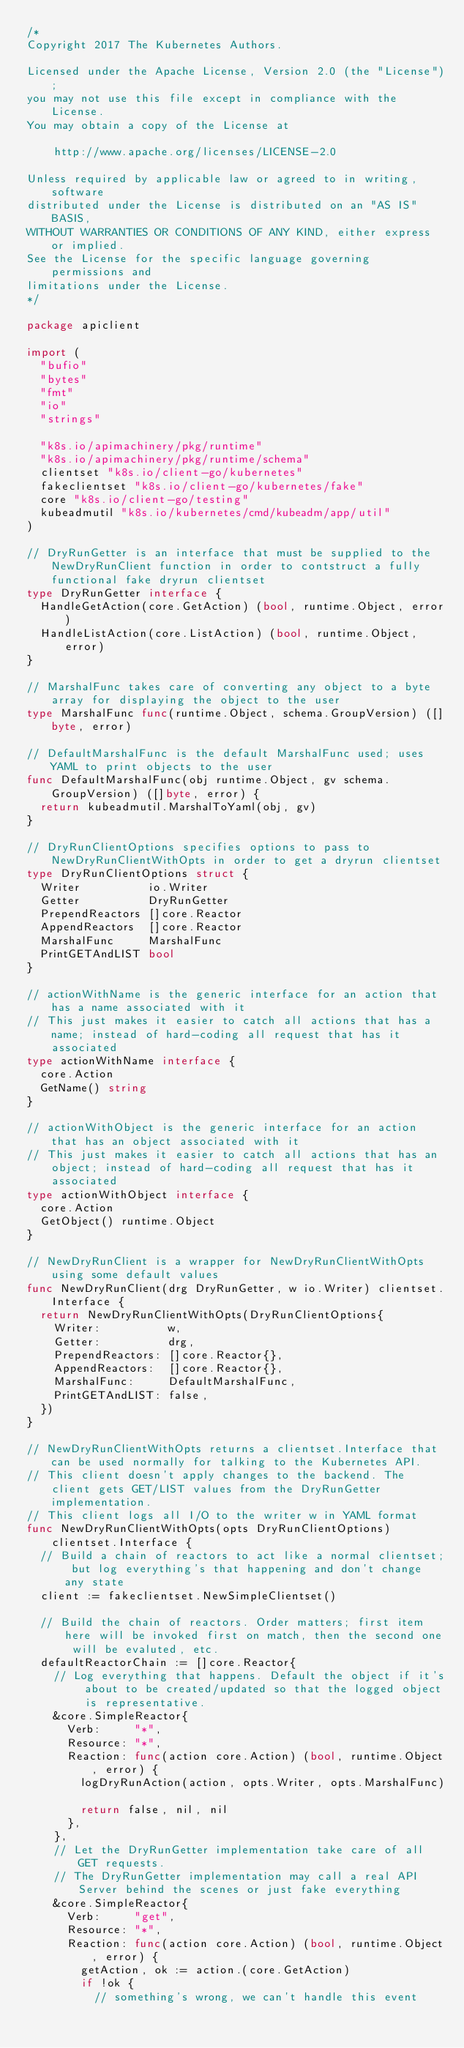Convert code to text. <code><loc_0><loc_0><loc_500><loc_500><_Go_>/*
Copyright 2017 The Kubernetes Authors.

Licensed under the Apache License, Version 2.0 (the "License");
you may not use this file except in compliance with the License.
You may obtain a copy of the License at

    http://www.apache.org/licenses/LICENSE-2.0

Unless required by applicable law or agreed to in writing, software
distributed under the License is distributed on an "AS IS" BASIS,
WITHOUT WARRANTIES OR CONDITIONS OF ANY KIND, either express or implied.
See the License for the specific language governing permissions and
limitations under the License.
*/

package apiclient

import (
	"bufio"
	"bytes"
	"fmt"
	"io"
	"strings"

	"k8s.io/apimachinery/pkg/runtime"
	"k8s.io/apimachinery/pkg/runtime/schema"
	clientset "k8s.io/client-go/kubernetes"
	fakeclientset "k8s.io/client-go/kubernetes/fake"
	core "k8s.io/client-go/testing"
	kubeadmutil "k8s.io/kubernetes/cmd/kubeadm/app/util"
)

// DryRunGetter is an interface that must be supplied to the NewDryRunClient function in order to contstruct a fully functional fake dryrun clientset
type DryRunGetter interface {
	HandleGetAction(core.GetAction) (bool, runtime.Object, error)
	HandleListAction(core.ListAction) (bool, runtime.Object, error)
}

// MarshalFunc takes care of converting any object to a byte array for displaying the object to the user
type MarshalFunc func(runtime.Object, schema.GroupVersion) ([]byte, error)

// DefaultMarshalFunc is the default MarshalFunc used; uses YAML to print objects to the user
func DefaultMarshalFunc(obj runtime.Object, gv schema.GroupVersion) ([]byte, error) {
	return kubeadmutil.MarshalToYaml(obj, gv)
}

// DryRunClientOptions specifies options to pass to NewDryRunClientWithOpts in order to get a dryrun clientset
type DryRunClientOptions struct {
	Writer          io.Writer
	Getter          DryRunGetter
	PrependReactors []core.Reactor
	AppendReactors  []core.Reactor
	MarshalFunc     MarshalFunc
	PrintGETAndLIST bool
}

// actionWithName is the generic interface for an action that has a name associated with it
// This just makes it easier to catch all actions that has a name; instead of hard-coding all request that has it associated
type actionWithName interface {
	core.Action
	GetName() string
}

// actionWithObject is the generic interface for an action that has an object associated with it
// This just makes it easier to catch all actions that has an object; instead of hard-coding all request that has it associated
type actionWithObject interface {
	core.Action
	GetObject() runtime.Object
}

// NewDryRunClient is a wrapper for NewDryRunClientWithOpts using some default values
func NewDryRunClient(drg DryRunGetter, w io.Writer) clientset.Interface {
	return NewDryRunClientWithOpts(DryRunClientOptions{
		Writer:          w,
		Getter:          drg,
		PrependReactors: []core.Reactor{},
		AppendReactors:  []core.Reactor{},
		MarshalFunc:     DefaultMarshalFunc,
		PrintGETAndLIST: false,
	})
}

// NewDryRunClientWithOpts returns a clientset.Interface that can be used normally for talking to the Kubernetes API.
// This client doesn't apply changes to the backend. The client gets GET/LIST values from the DryRunGetter implementation.
// This client logs all I/O to the writer w in YAML format
func NewDryRunClientWithOpts(opts DryRunClientOptions) clientset.Interface {
	// Build a chain of reactors to act like a normal clientset; but log everything's that happening and don't change any state
	client := fakeclientset.NewSimpleClientset()

	// Build the chain of reactors. Order matters; first item here will be invoked first on match, then the second one will be evaluted, etc.
	defaultReactorChain := []core.Reactor{
		// Log everything that happens. Default the object if it's about to be created/updated so that the logged object is representative.
		&core.SimpleReactor{
			Verb:     "*",
			Resource: "*",
			Reaction: func(action core.Action) (bool, runtime.Object, error) {
				logDryRunAction(action, opts.Writer, opts.MarshalFunc)

				return false, nil, nil
			},
		},
		// Let the DryRunGetter implementation take care of all GET requests.
		// The DryRunGetter implementation may call a real API Server behind the scenes or just fake everything
		&core.SimpleReactor{
			Verb:     "get",
			Resource: "*",
			Reaction: func(action core.Action) (bool, runtime.Object, error) {
				getAction, ok := action.(core.GetAction)
				if !ok {
					// something's wrong, we can't handle this event</code> 